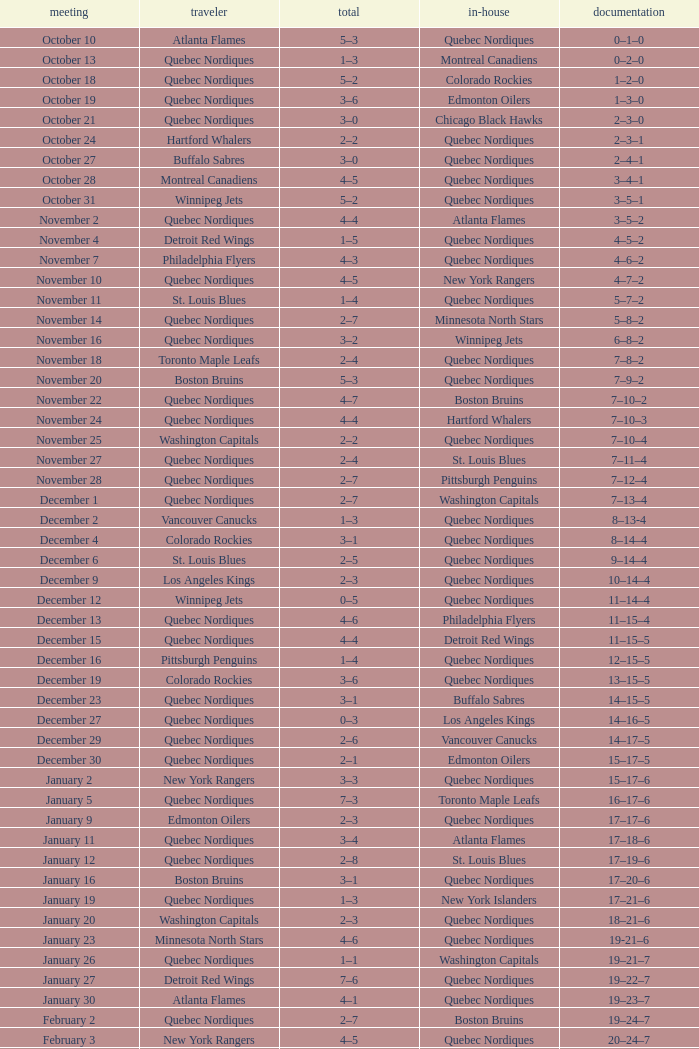Which Home has a Date of april 1? Quebec Nordiques. 